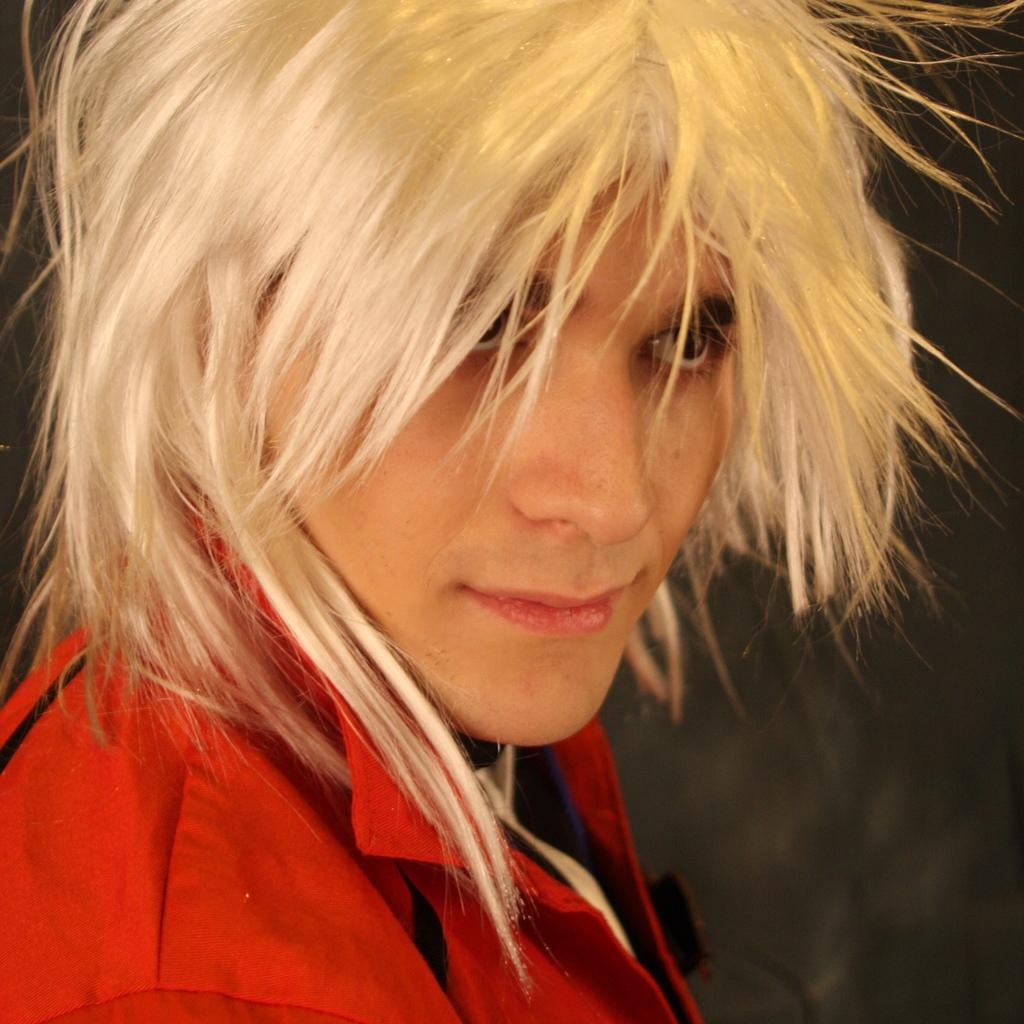Who is present in the image? There is a person in the image. What is the person doing in the image? The person is standing on the floor. What type of ticket does the person have in their hand in the image? There is no ticket present in the image; the person is simply standing on the floor. 